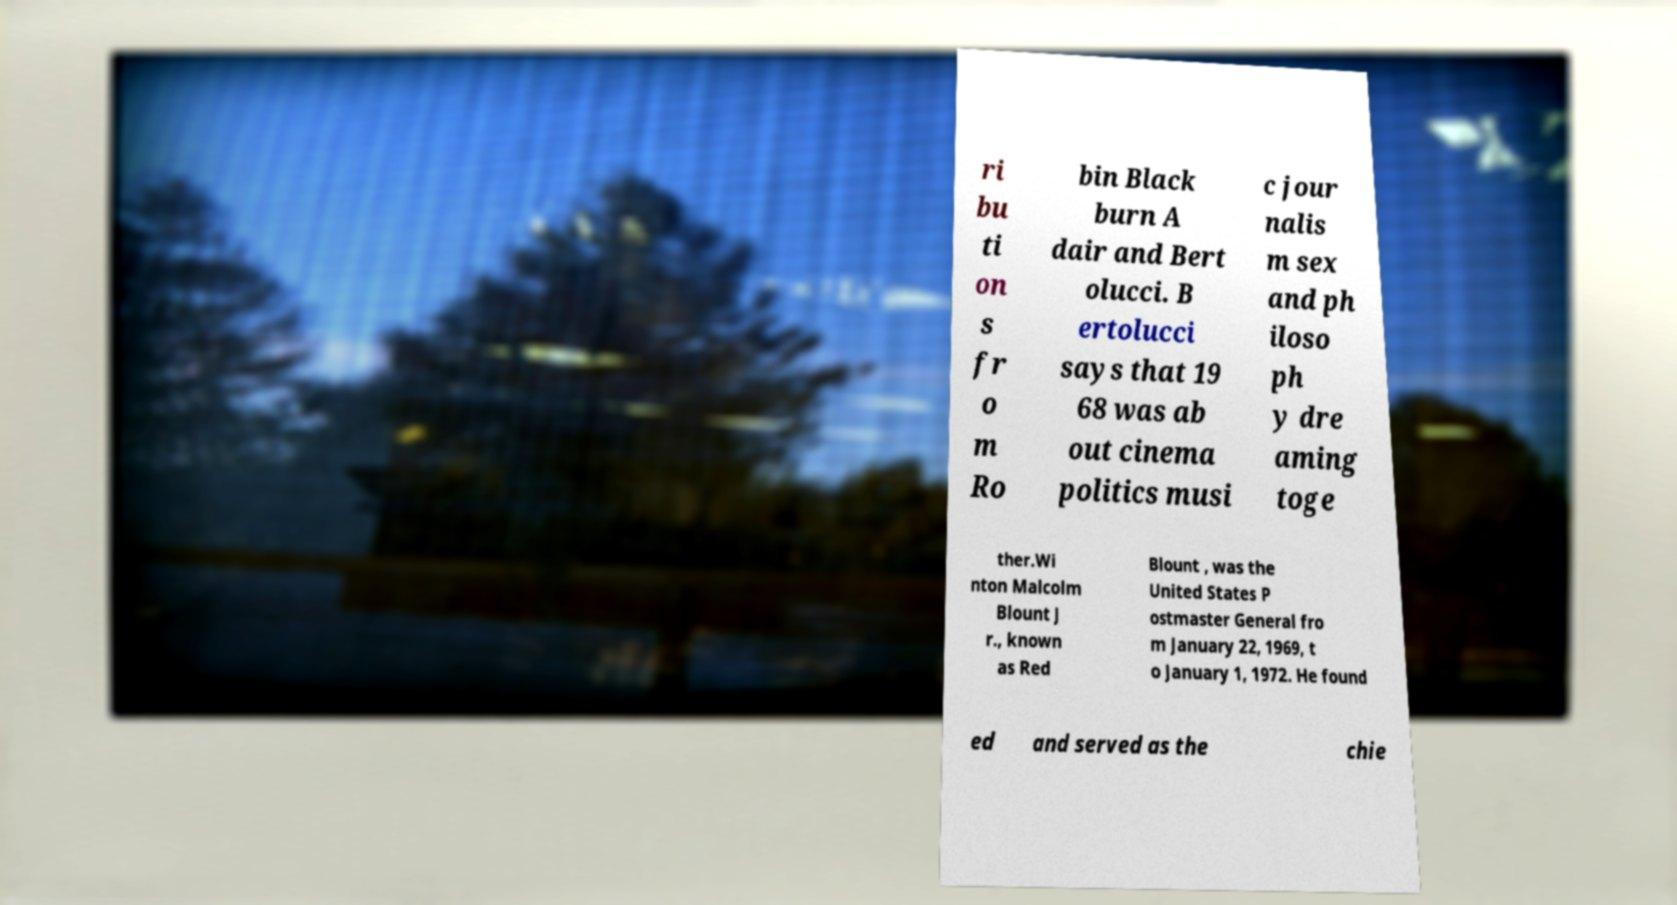Please identify and transcribe the text found in this image. ri bu ti on s fr o m Ro bin Black burn A dair and Bert olucci. B ertolucci says that 19 68 was ab out cinema politics musi c jour nalis m sex and ph iloso ph y dre aming toge ther.Wi nton Malcolm Blount J r., known as Red Blount , was the United States P ostmaster General fro m January 22, 1969, t o January 1, 1972. He found ed and served as the chie 